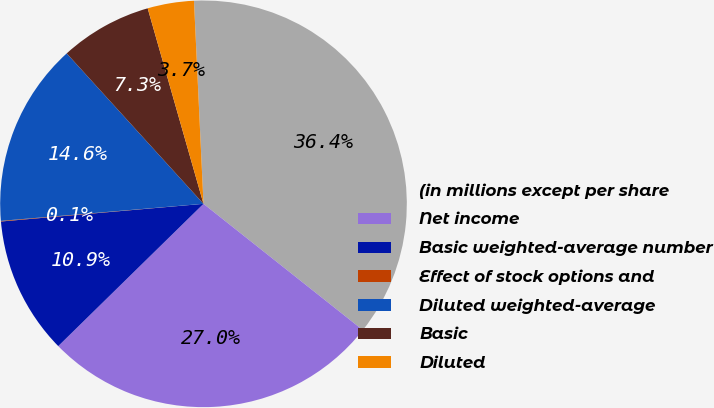Convert chart. <chart><loc_0><loc_0><loc_500><loc_500><pie_chart><fcel>(in millions except per share<fcel>Net income<fcel>Basic weighted-average number<fcel>Effect of stock options and<fcel>Diluted weighted-average<fcel>Basic<fcel>Diluted<nl><fcel>36.41%<fcel>27.0%<fcel>10.95%<fcel>0.05%<fcel>14.59%<fcel>7.32%<fcel>3.68%<nl></chart> 